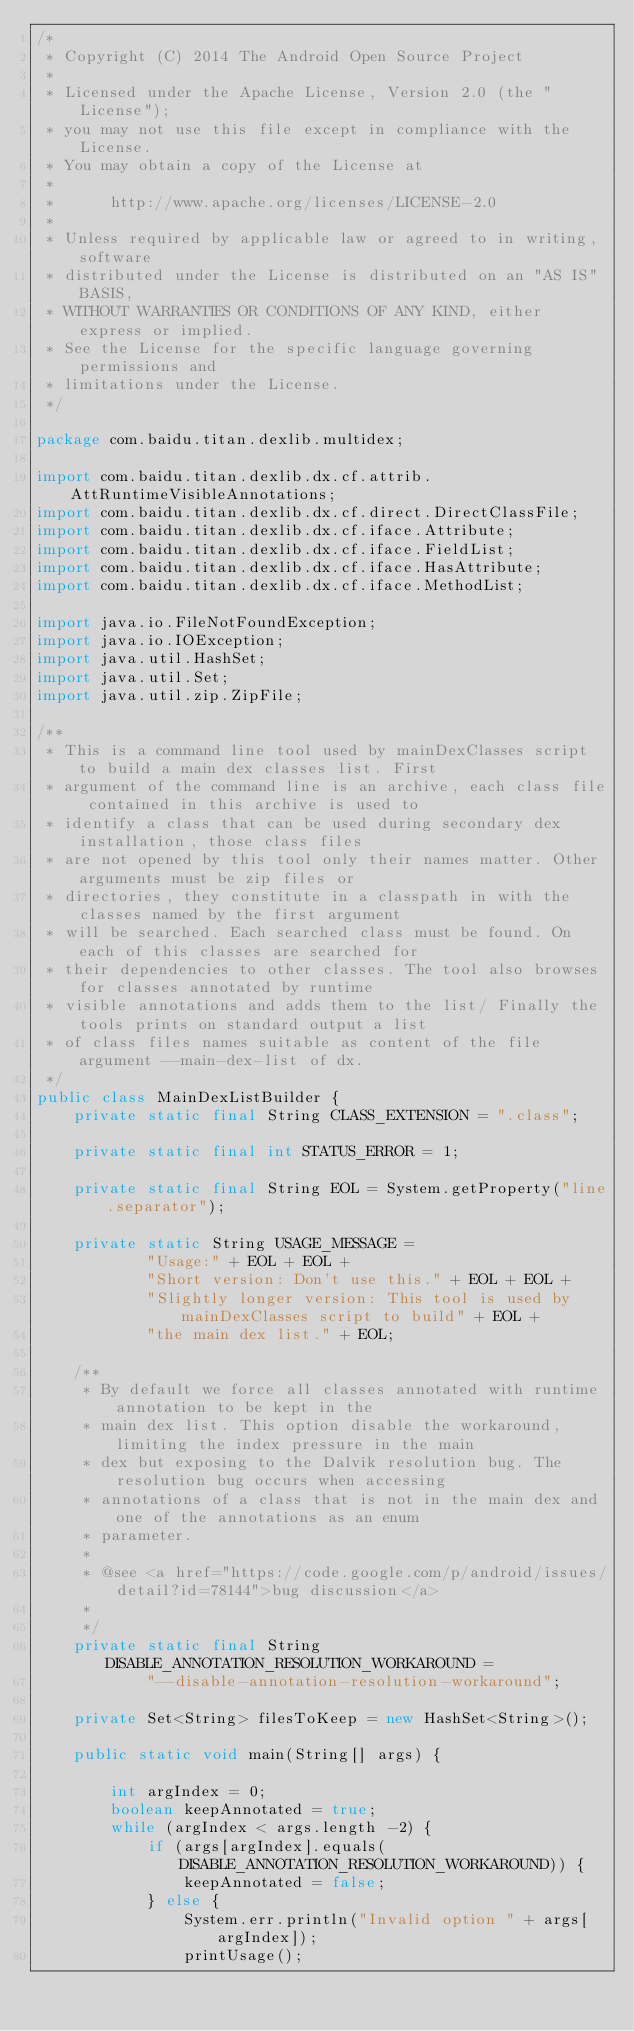<code> <loc_0><loc_0><loc_500><loc_500><_Java_>/*
 * Copyright (C) 2014 The Android Open Source Project
 *
 * Licensed under the Apache License, Version 2.0 (the "License");
 * you may not use this file except in compliance with the License.
 * You may obtain a copy of the License at
 *
 *      http://www.apache.org/licenses/LICENSE-2.0
 *
 * Unless required by applicable law or agreed to in writing, software
 * distributed under the License is distributed on an "AS IS" BASIS,
 * WITHOUT WARRANTIES OR CONDITIONS OF ANY KIND, either express or implied.
 * See the License for the specific language governing permissions and
 * limitations under the License.
 */

package com.baidu.titan.dexlib.multidex;

import com.baidu.titan.dexlib.dx.cf.attrib.AttRuntimeVisibleAnnotations;
import com.baidu.titan.dexlib.dx.cf.direct.DirectClassFile;
import com.baidu.titan.dexlib.dx.cf.iface.Attribute;
import com.baidu.titan.dexlib.dx.cf.iface.FieldList;
import com.baidu.titan.dexlib.dx.cf.iface.HasAttribute;
import com.baidu.titan.dexlib.dx.cf.iface.MethodList;

import java.io.FileNotFoundException;
import java.io.IOException;
import java.util.HashSet;
import java.util.Set;
import java.util.zip.ZipFile;

/**
 * This is a command line tool used by mainDexClasses script to build a main dex classes list. First
 * argument of the command line is an archive, each class file contained in this archive is used to
 * identify a class that can be used during secondary dex installation, those class files
 * are not opened by this tool only their names matter. Other arguments must be zip files or
 * directories, they constitute in a classpath in with the classes named by the first argument
 * will be searched. Each searched class must be found. On each of this classes are searched for
 * their dependencies to other classes. The tool also browses for classes annotated by runtime
 * visible annotations and adds them to the list/ Finally the tools prints on standard output a list
 * of class files names suitable as content of the file argument --main-dex-list of dx.
 */
public class MainDexListBuilder {
    private static final String CLASS_EXTENSION = ".class";

    private static final int STATUS_ERROR = 1;

    private static final String EOL = System.getProperty("line.separator");

    private static String USAGE_MESSAGE =
            "Usage:" + EOL + EOL +
            "Short version: Don't use this." + EOL + EOL +
            "Slightly longer version: This tool is used by mainDexClasses script to build" + EOL +
            "the main dex list." + EOL;

    /**
     * By default we force all classes annotated with runtime annotation to be kept in the
     * main dex list. This option disable the workaround, limiting the index pressure in the main
     * dex but exposing to the Dalvik resolution bug. The resolution bug occurs when accessing
     * annotations of a class that is not in the main dex and one of the annotations as an enum
     * parameter.
     *
     * @see <a href="https://code.google.com/p/android/issues/detail?id=78144">bug discussion</a>
     *
     */
    private static final String DISABLE_ANNOTATION_RESOLUTION_WORKAROUND =
            "--disable-annotation-resolution-workaround";

    private Set<String> filesToKeep = new HashSet<String>();

    public static void main(String[] args) {

        int argIndex = 0;
        boolean keepAnnotated = true;
        while (argIndex < args.length -2) {
            if (args[argIndex].equals(DISABLE_ANNOTATION_RESOLUTION_WORKAROUND)) {
                keepAnnotated = false;
            } else {
                System.err.println("Invalid option " + args[argIndex]);
                printUsage();</code> 